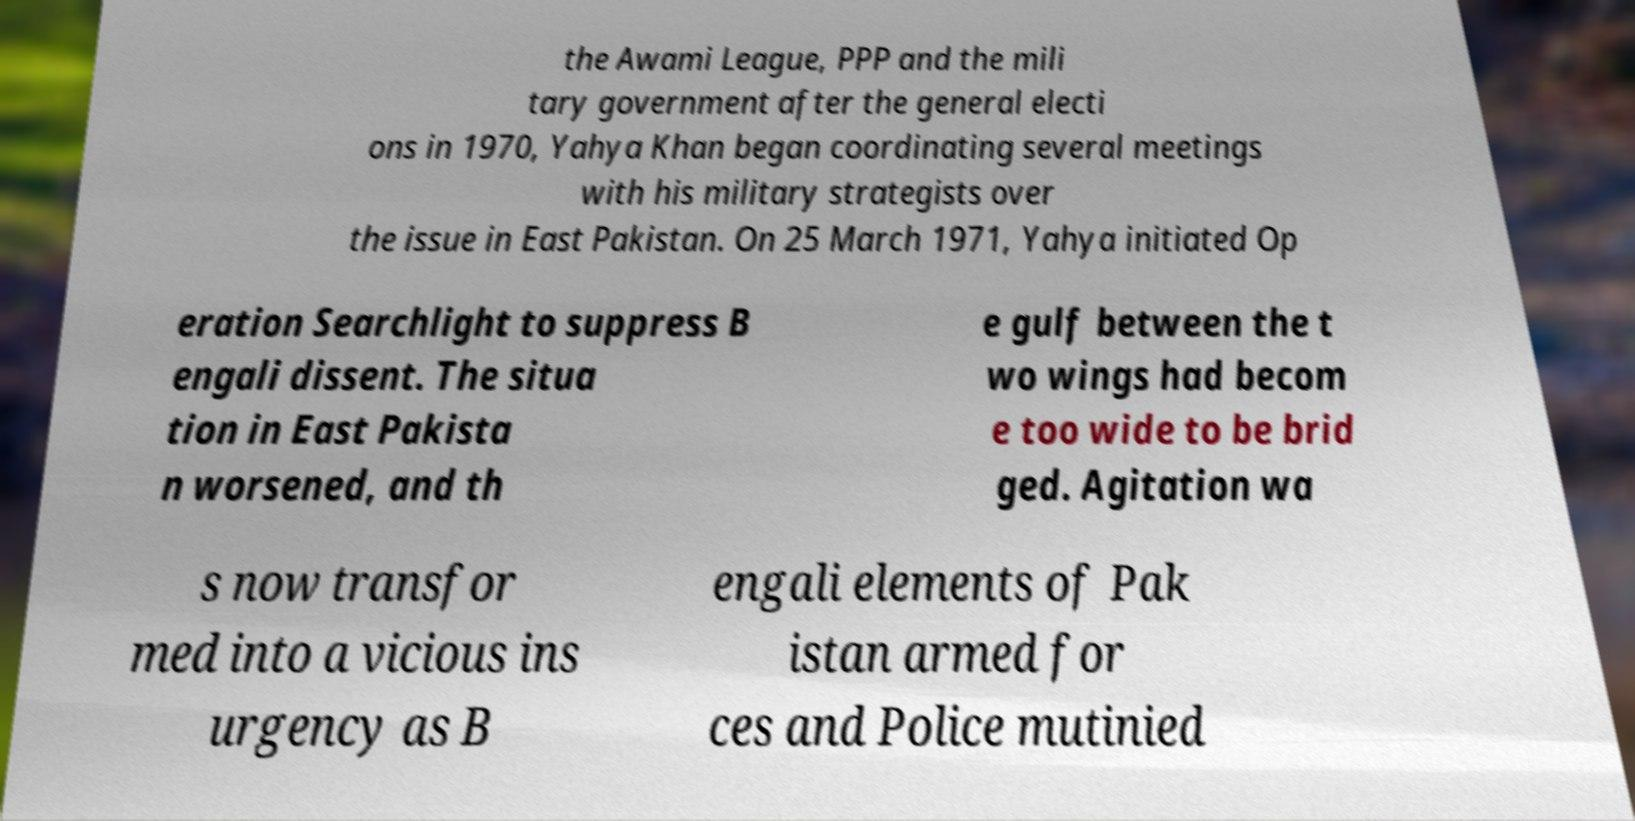I need the written content from this picture converted into text. Can you do that? the Awami League, PPP and the mili tary government after the general electi ons in 1970, Yahya Khan began coordinating several meetings with his military strategists over the issue in East Pakistan. On 25 March 1971, Yahya initiated Op eration Searchlight to suppress B engali dissent. The situa tion in East Pakista n worsened, and th e gulf between the t wo wings had becom e too wide to be brid ged. Agitation wa s now transfor med into a vicious ins urgency as B engali elements of Pak istan armed for ces and Police mutinied 